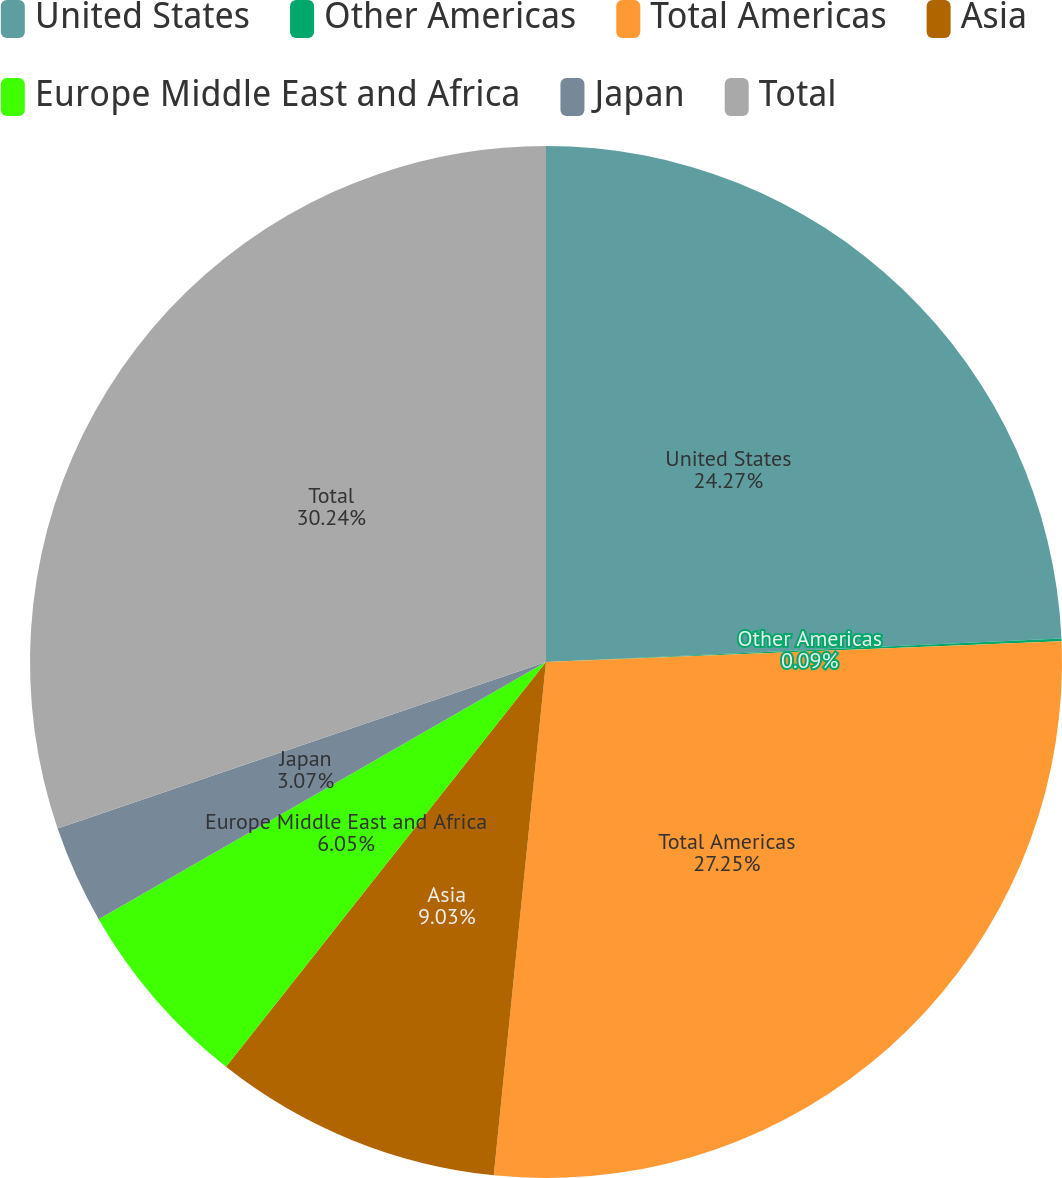Convert chart. <chart><loc_0><loc_0><loc_500><loc_500><pie_chart><fcel>United States<fcel>Other Americas<fcel>Total Americas<fcel>Asia<fcel>Europe Middle East and Africa<fcel>Japan<fcel>Total<nl><fcel>24.27%<fcel>0.09%<fcel>27.25%<fcel>9.03%<fcel>6.05%<fcel>3.07%<fcel>30.23%<nl></chart> 